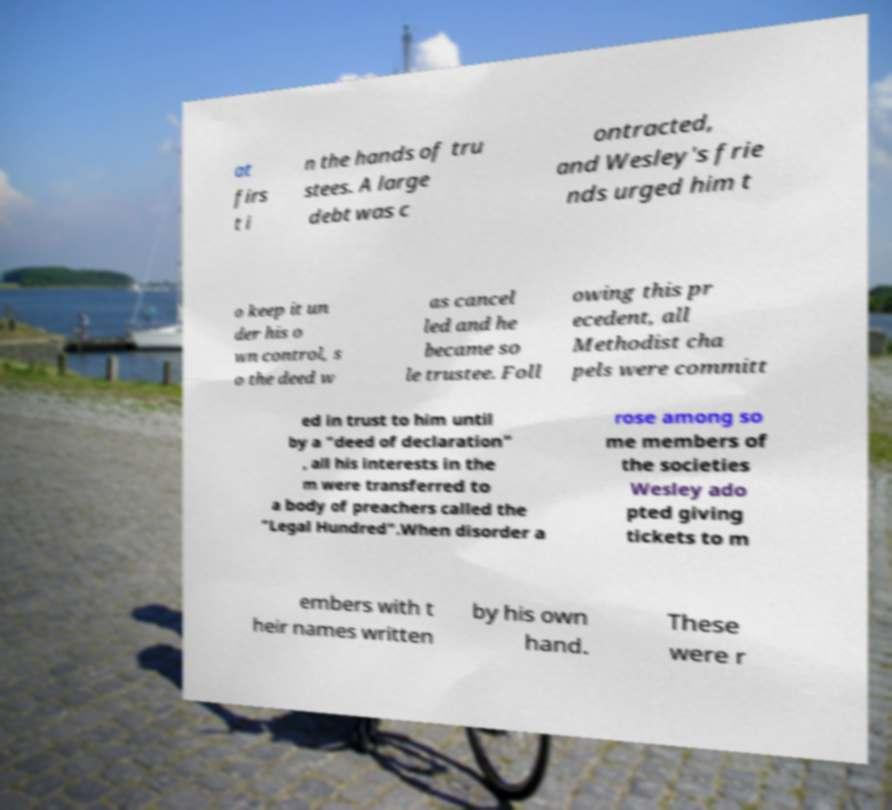Could you extract and type out the text from this image? at firs t i n the hands of tru stees. A large debt was c ontracted, and Wesley's frie nds urged him t o keep it un der his o wn control, s o the deed w as cancel led and he became so le trustee. Foll owing this pr ecedent, all Methodist cha pels were committ ed in trust to him until by a "deed of declaration" , all his interests in the m were transferred to a body of preachers called the "Legal Hundred".When disorder a rose among so me members of the societies Wesley ado pted giving tickets to m embers with t heir names written by his own hand. These were r 